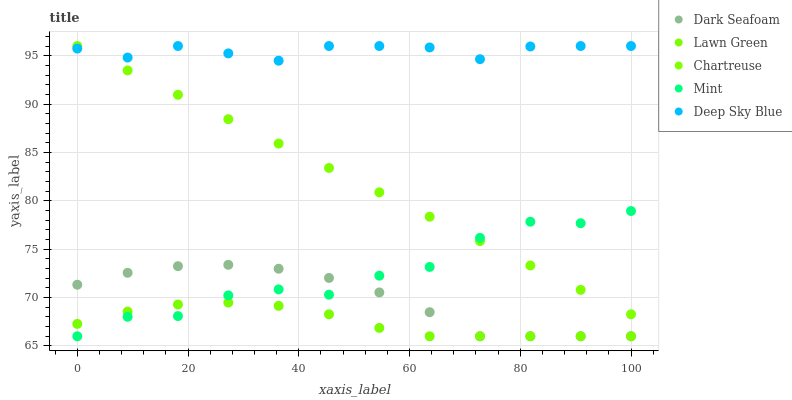Does Lawn Green have the minimum area under the curve?
Answer yes or no. Yes. Does Deep Sky Blue have the maximum area under the curve?
Answer yes or no. Yes. Does Dark Seafoam have the minimum area under the curve?
Answer yes or no. No. Does Dark Seafoam have the maximum area under the curve?
Answer yes or no. No. Is Chartreuse the smoothest?
Answer yes or no. Yes. Is Mint the roughest?
Answer yes or no. Yes. Is Dark Seafoam the smoothest?
Answer yes or no. No. Is Dark Seafoam the roughest?
Answer yes or no. No. Does Lawn Green have the lowest value?
Answer yes or no. Yes. Does Chartreuse have the lowest value?
Answer yes or no. No. Does Deep Sky Blue have the highest value?
Answer yes or no. Yes. Does Dark Seafoam have the highest value?
Answer yes or no. No. Is Dark Seafoam less than Chartreuse?
Answer yes or no. Yes. Is Chartreuse greater than Dark Seafoam?
Answer yes or no. Yes. Does Deep Sky Blue intersect Chartreuse?
Answer yes or no. Yes. Is Deep Sky Blue less than Chartreuse?
Answer yes or no. No. Is Deep Sky Blue greater than Chartreuse?
Answer yes or no. No. Does Dark Seafoam intersect Chartreuse?
Answer yes or no. No. 